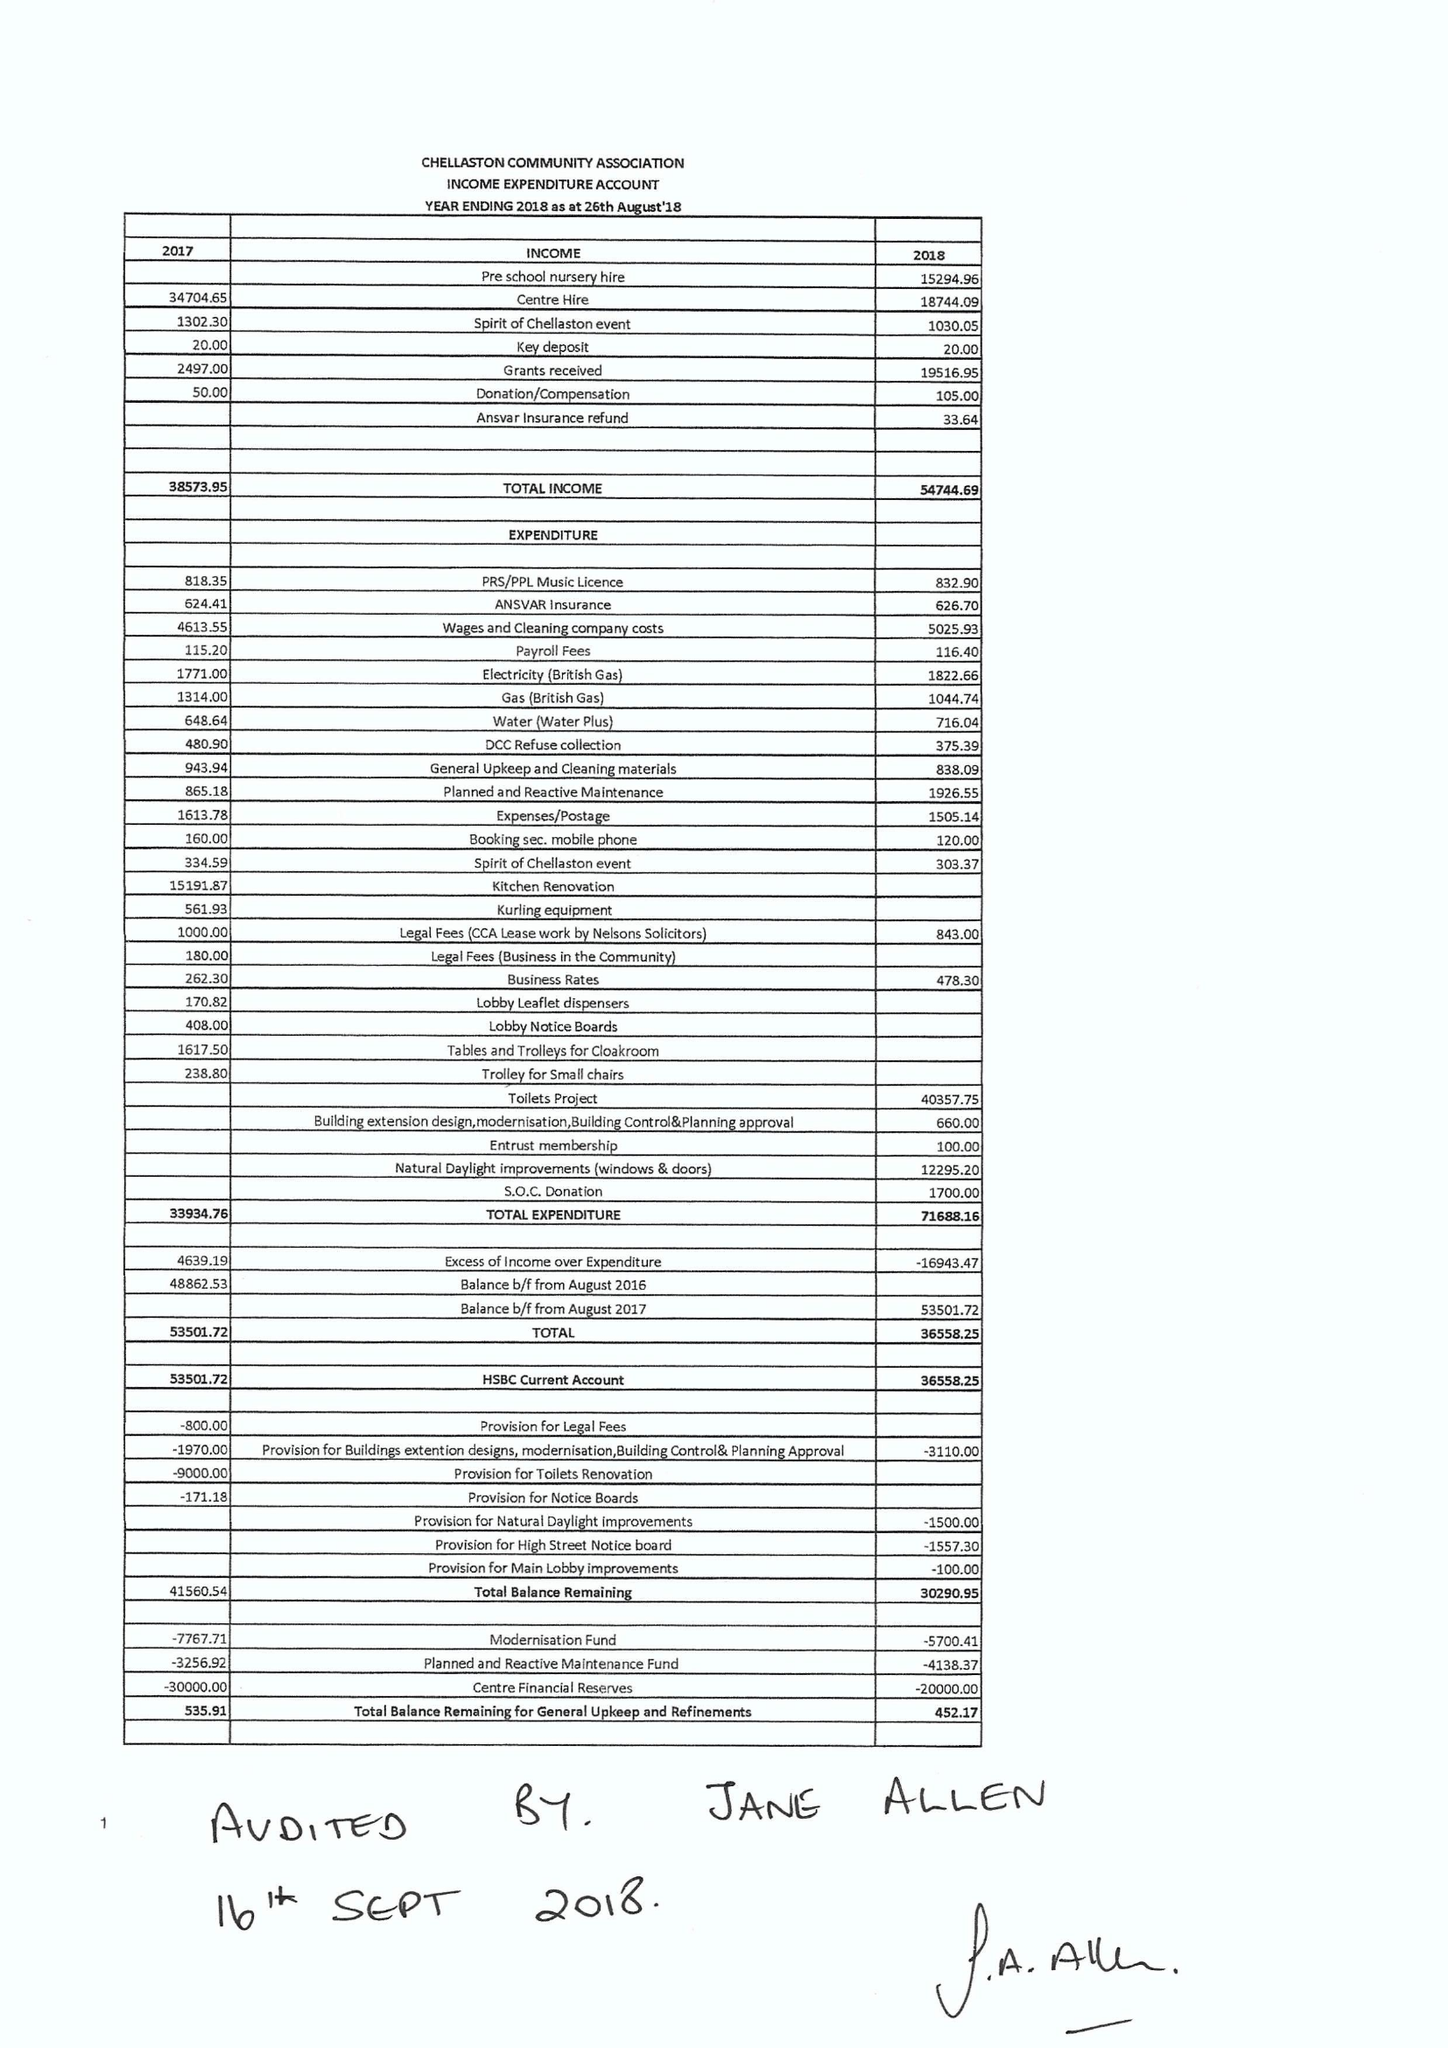What is the value for the spending_annually_in_british_pounds?
Answer the question using a single word or phrase. 71688.00 